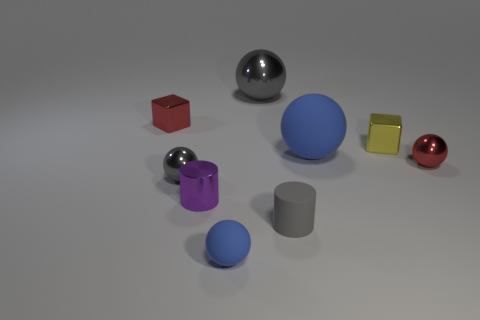Subtract all green cylinders. How many blue balls are left? 2 Subtract all big gray balls. How many balls are left? 4 Subtract all cylinders. How many objects are left? 7 Subtract all tiny gray matte cylinders. Subtract all purple things. How many objects are left? 7 Add 5 blue things. How many blue things are left? 7 Add 1 small yellow metal spheres. How many small yellow metal spheres exist? 1 Subtract all yellow cubes. How many cubes are left? 1 Subtract 0 red cylinders. How many objects are left? 9 Subtract 2 cubes. How many cubes are left? 0 Subtract all blue balls. Subtract all gray cylinders. How many balls are left? 3 